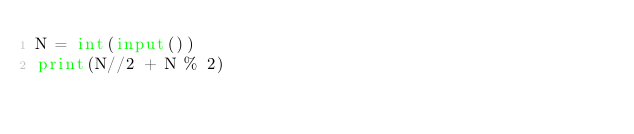Convert code to text. <code><loc_0><loc_0><loc_500><loc_500><_Python_>N = int(input())
print(N//2 + N % 2)</code> 